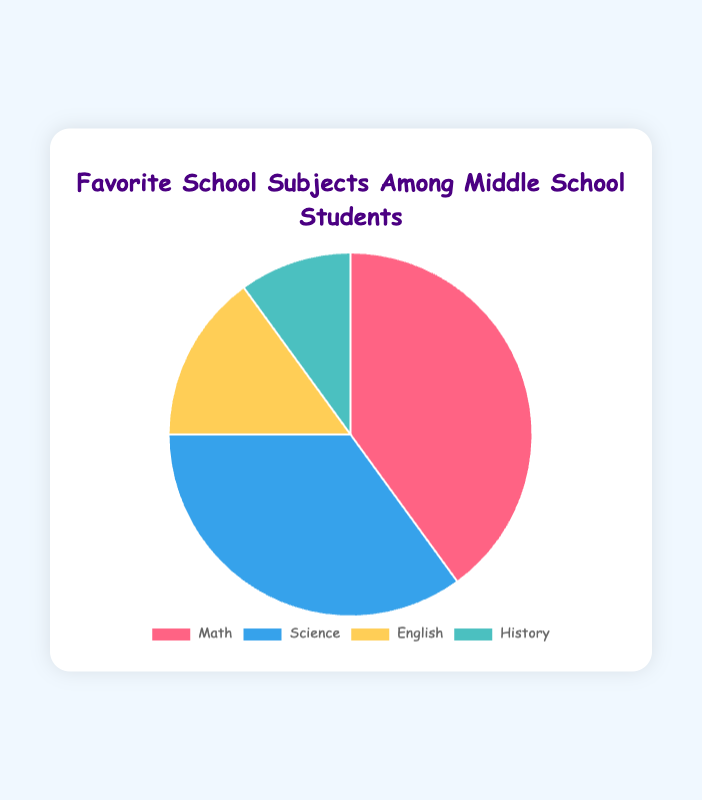What's the most popular school subject among middle school students? The pie chart shows the distribution of favorite subjects, and the largest slice corresponds to Math with 40 students.
Answer: Math Which subject is the least popular among the students? By looking at the smallest slice of the pie chart, it corresponds to History which has the fewest students.
Answer: History How many more students prefer Science over History? The chart shows 35 students prefer Science and 10 prefer History. Subtract the two to find the difference: 35 - 10 = 25.
Answer: 25 What is the combined percentage of students who prefer English and History? The chart shows 15 students like English and 10 like History. Together, that is 15 + 10 = 25 students. The total number of students is 40 + 35 + 15 + 10 = 100, so the combined percentage is (25/100) * 100 = 25%.
Answer: 25% Compare the number of students who like Math with those who like Science. Which is larger and by how much? Math has 40 students and Science has 35 students. Math has 5 more students than Science (40 - 35 = 5).
Answer: Math; 5 students If you combine the students who like English and History, will it be more than those who like Science? The number of students who like English and History combined is 15 + 10 = 25. This is less than the 35 students who like Science.
Answer: No What percentage of students prefer Math? There are 40 students who prefer Math out of a total of 100 students. So the percentage is (40/100) * 100 = 40%.
Answer: 40% What's the ratio of students who prefer Science to those who prefer English? There are 35 students for Science and 15 for English. The ratio can be simplified from 35:15 to 7:3.
Answer: 7:3 Which subject has the second highest number of students? The pie chart indicates that the second largest slice corresponds to Science with 35 students.
Answer: Science If 5 more students decided to prefer History, what would the new total for History be? Currently, 10 students prefer History. Adding 5 more students makes the new total 10 + 5 = 15.
Answer: 15 